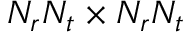<formula> <loc_0><loc_0><loc_500><loc_500>N _ { r } N _ { t } \times N _ { r } N _ { t }</formula> 